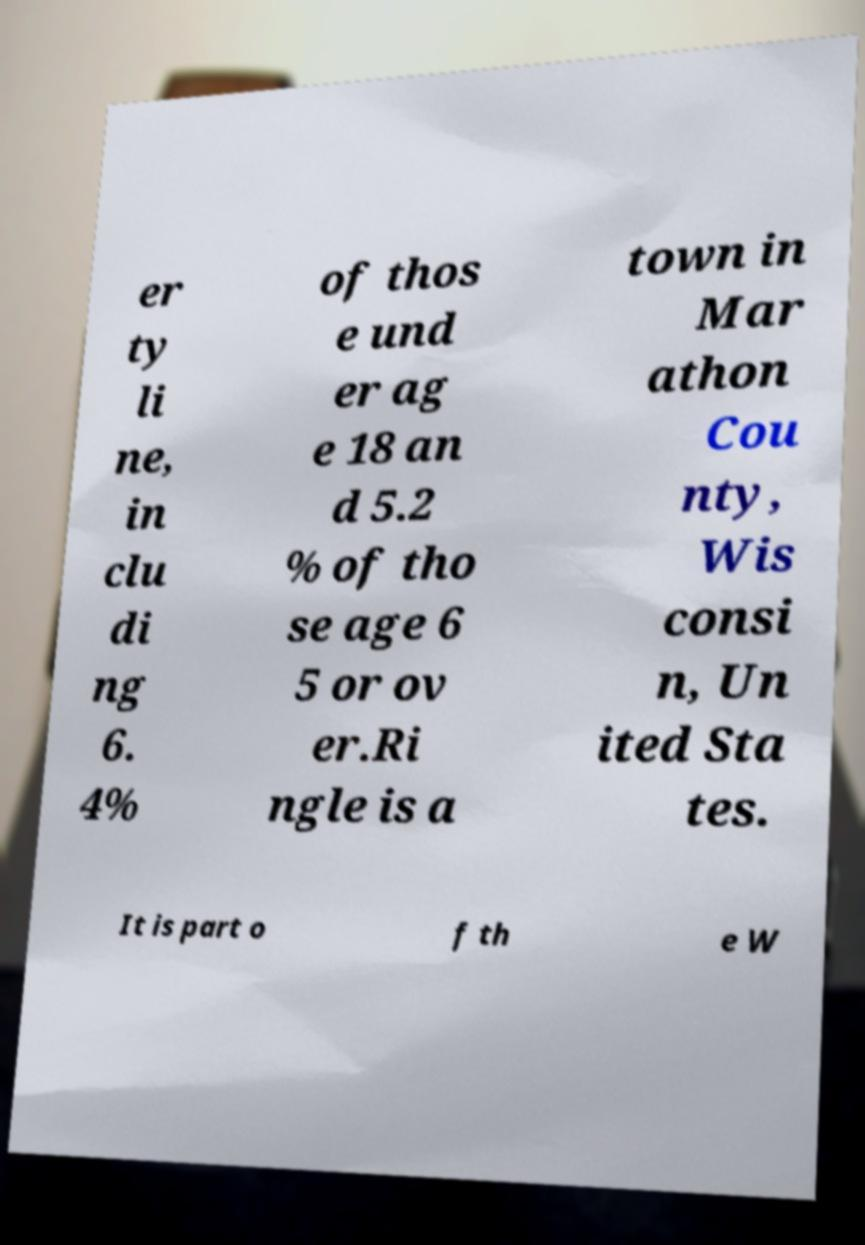I need the written content from this picture converted into text. Can you do that? er ty li ne, in clu di ng 6. 4% of thos e und er ag e 18 an d 5.2 % of tho se age 6 5 or ov er.Ri ngle is a town in Mar athon Cou nty, Wis consi n, Un ited Sta tes. It is part o f th e W 